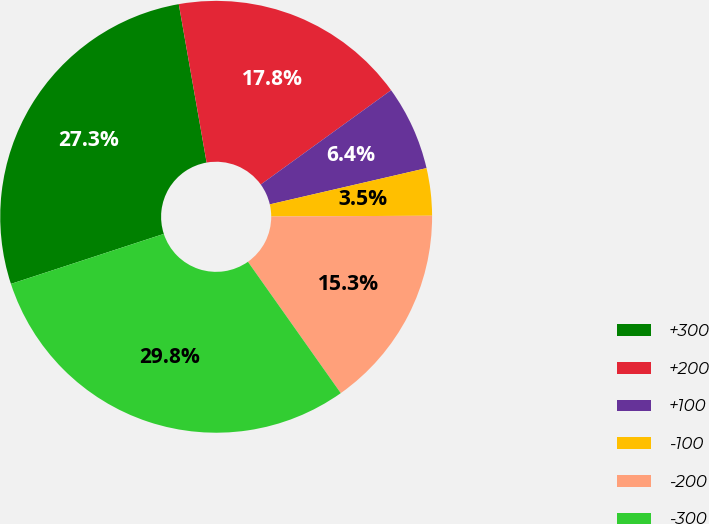<chart> <loc_0><loc_0><loc_500><loc_500><pie_chart><fcel>+300<fcel>+200<fcel>+100<fcel>-100<fcel>-200<fcel>-300<nl><fcel>27.26%<fcel>17.8%<fcel>6.35%<fcel>3.54%<fcel>15.29%<fcel>29.76%<nl></chart> 